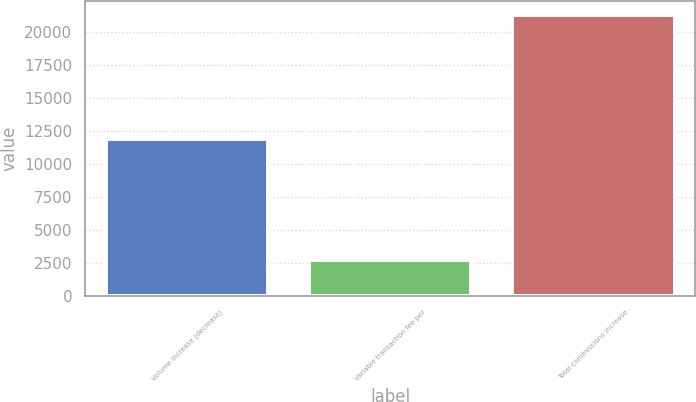Convert chart to OTSL. <chart><loc_0><loc_0><loc_500><loc_500><bar_chart><fcel>Volume increase (decrease)<fcel>Variable transaction fee per<fcel>Total commissions increase<nl><fcel>11865<fcel>2738<fcel>21239<nl></chart> 